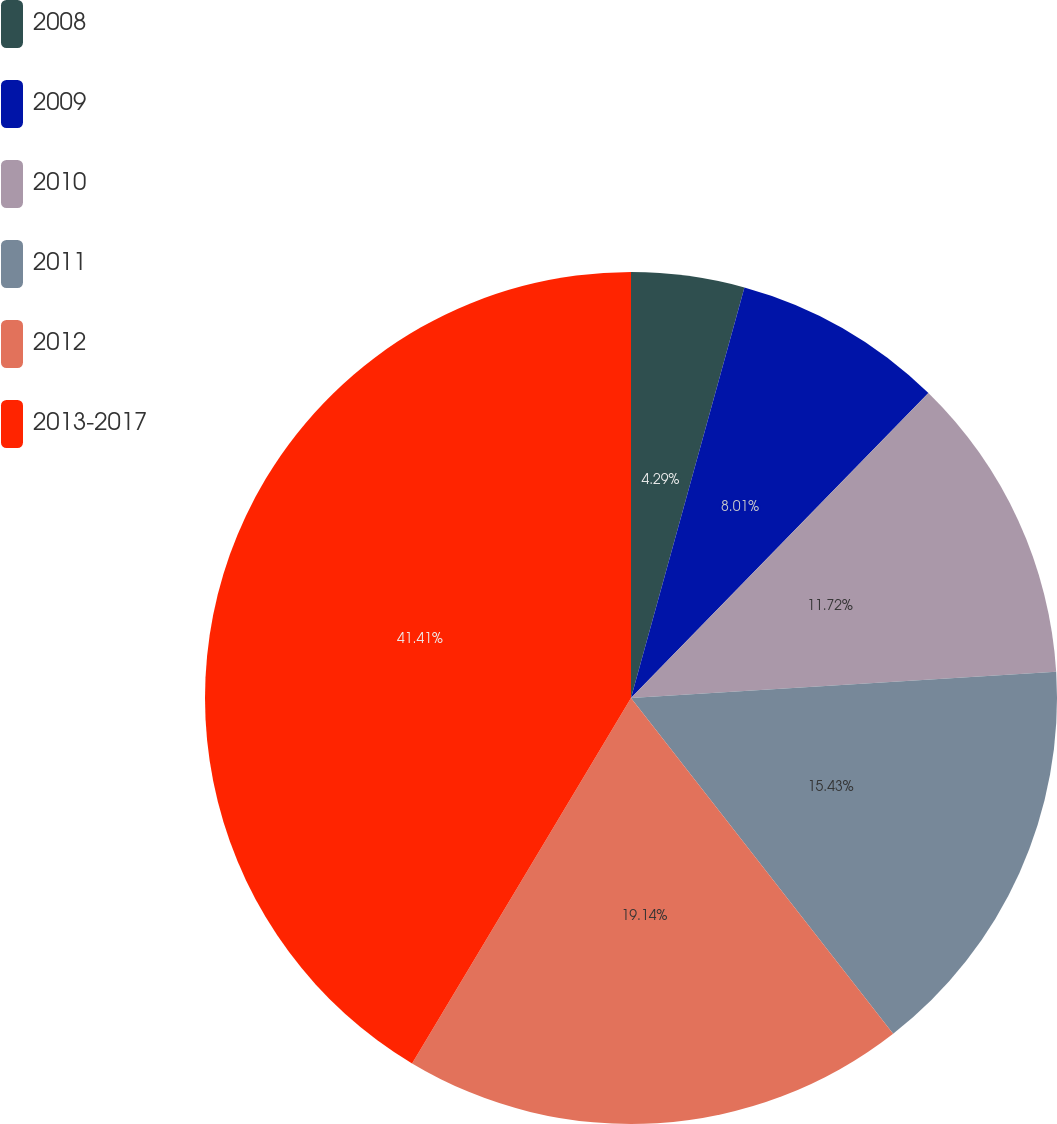Convert chart. <chart><loc_0><loc_0><loc_500><loc_500><pie_chart><fcel>2008<fcel>2009<fcel>2010<fcel>2011<fcel>2012<fcel>2013-2017<nl><fcel>4.29%<fcel>8.01%<fcel>11.72%<fcel>15.43%<fcel>19.14%<fcel>41.41%<nl></chart> 